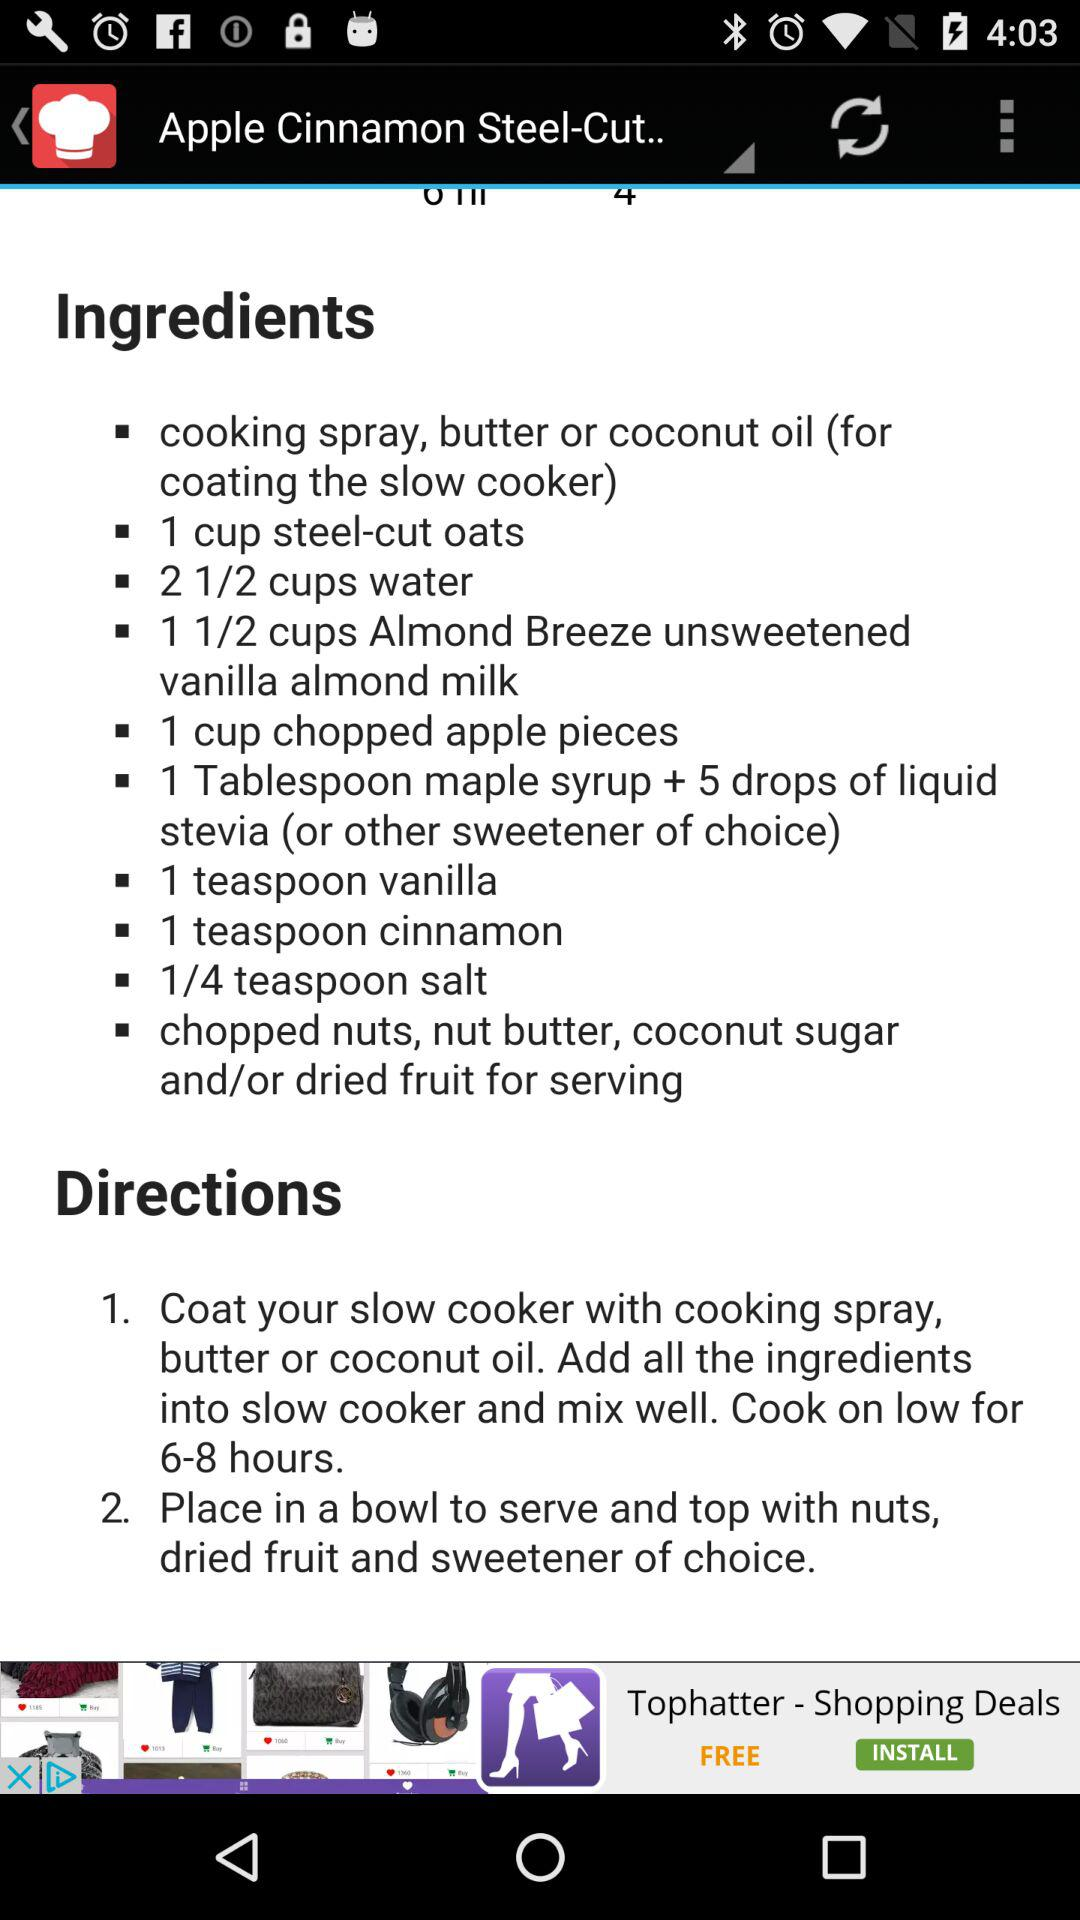What are the ingredients required for the recipe? The ingredients required for the recipe are "cooking spray, butter or coconut oil (for coating the slow cooker)", "1 cup steel-cut oats", "2 1/2 cups water", "1 1/2 cups Almond Breeze unsweetened vanilla almond milk", "1 cup chopped apple pieces", "1 Tablespoon maple syrup + 5 drops of liquid stevia (or other sweetener of choice)", "1 teaspoon vanilla", "1 teaspoon cinnamon", "1/4 teaspoon salt" and "chopped nuts, nut butter, coconut sugar and/or dried fruit for serving". 